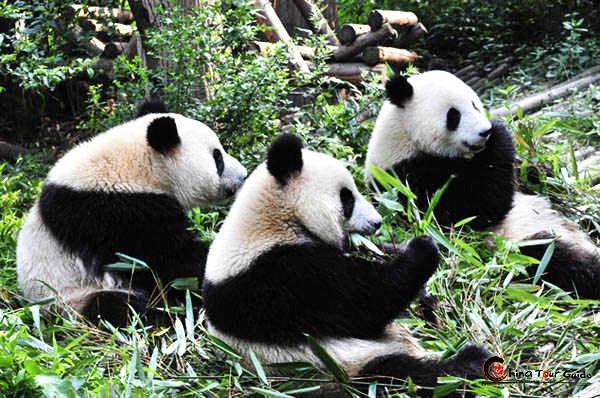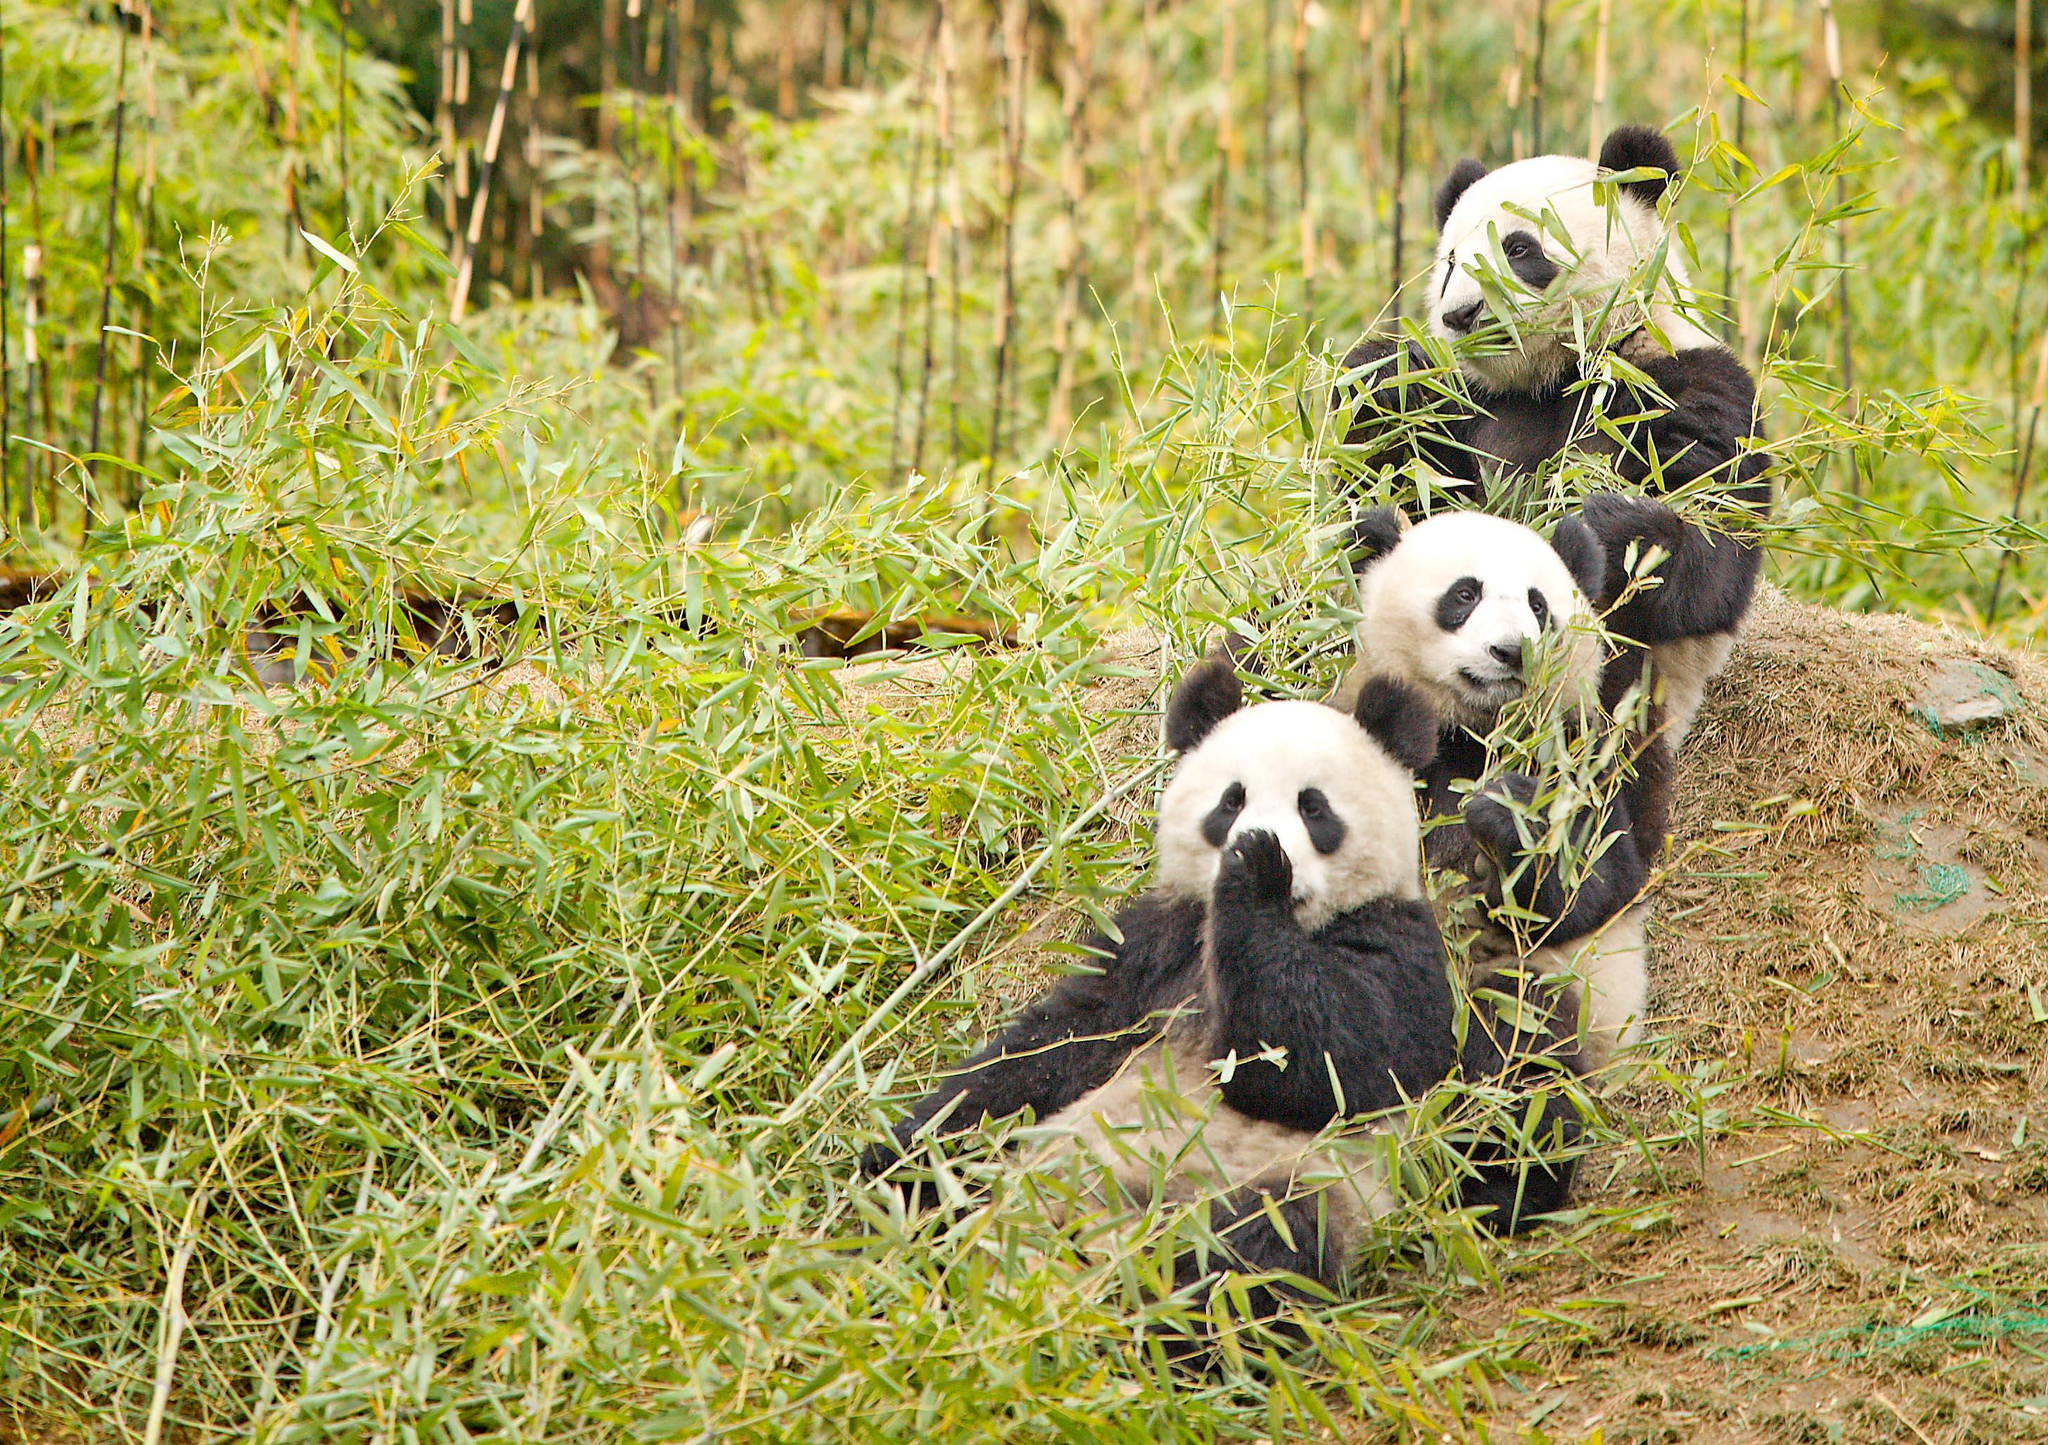The first image is the image on the left, the second image is the image on the right. Assess this claim about the two images: "There are more than 4 pandas.". Correct or not? Answer yes or no. Yes. The first image is the image on the left, the second image is the image on the right. Considering the images on both sides, is "The left image contains exactly one panda." valid? Answer yes or no. No. 